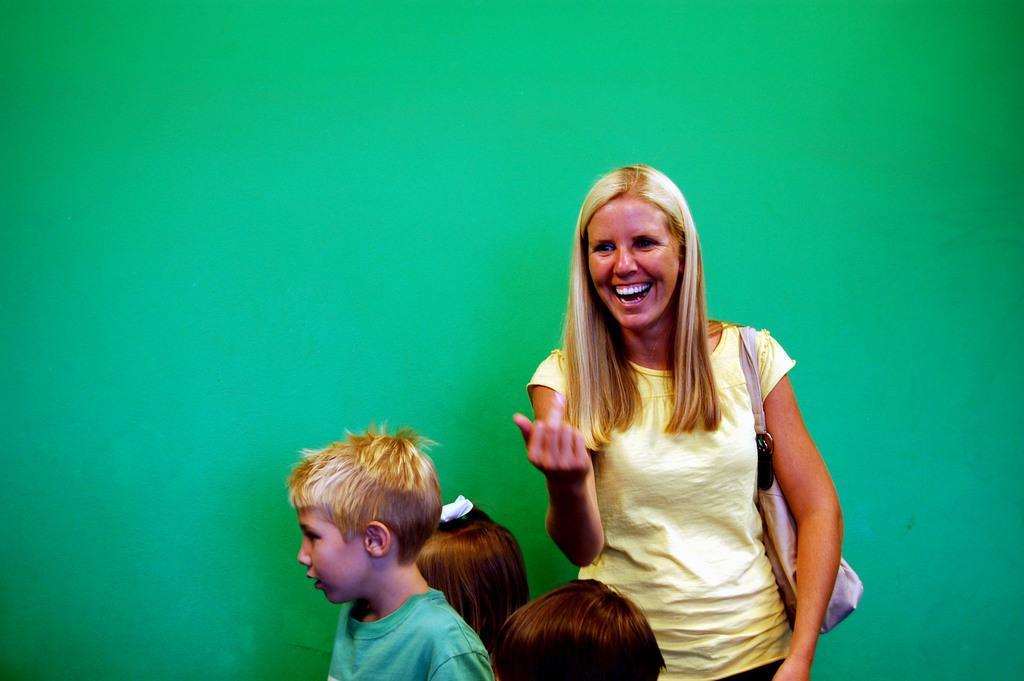How would you summarize this image in a sentence or two? There is a woman wearing yellow dress is standing and laughing and there are three kids beside her and the background wall is green in color. 